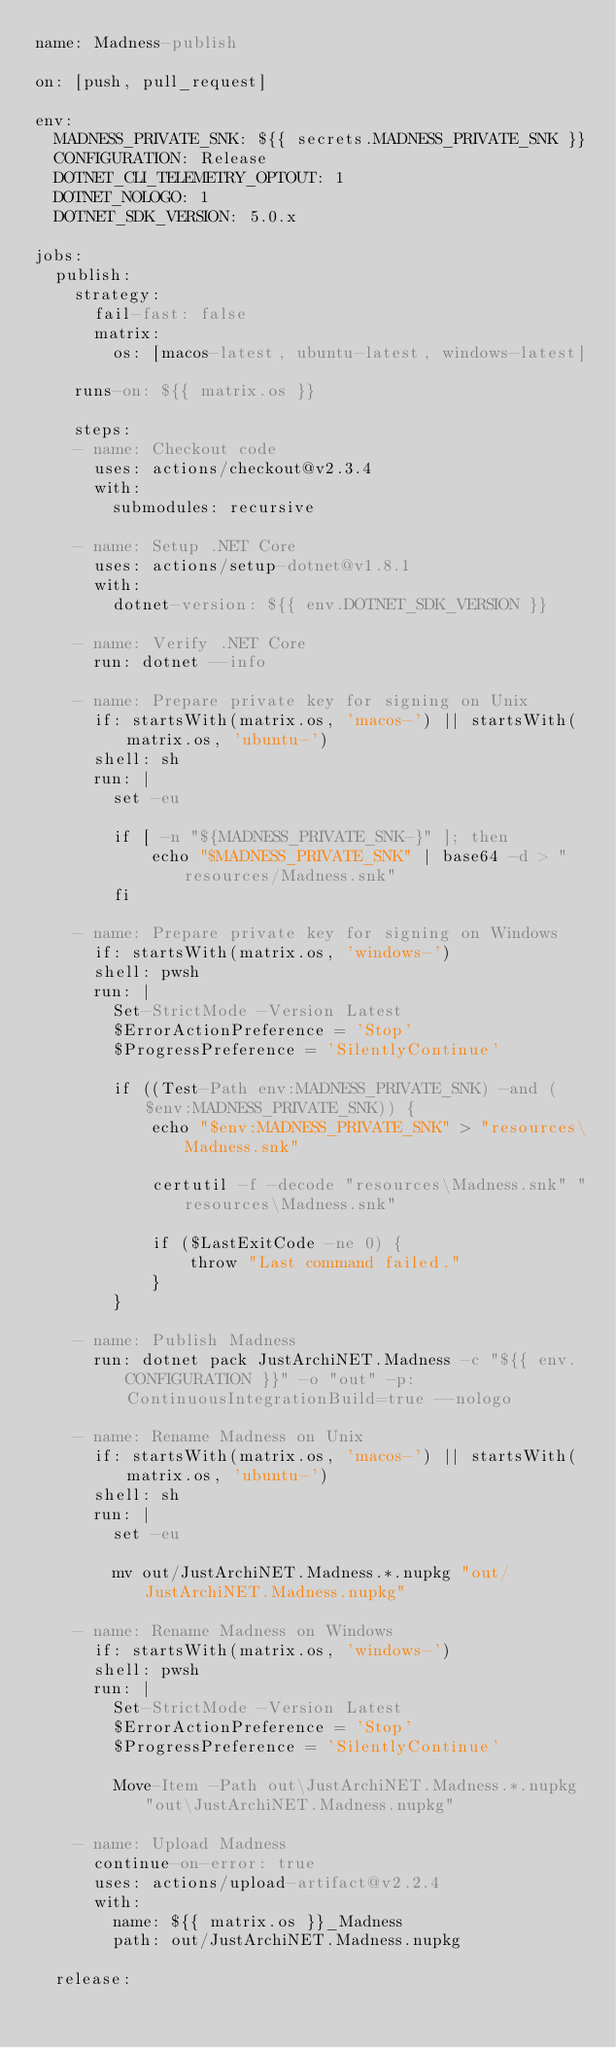<code> <loc_0><loc_0><loc_500><loc_500><_YAML_>name: Madness-publish

on: [push, pull_request]

env:
  MADNESS_PRIVATE_SNK: ${{ secrets.MADNESS_PRIVATE_SNK }}
  CONFIGURATION: Release
  DOTNET_CLI_TELEMETRY_OPTOUT: 1
  DOTNET_NOLOGO: 1
  DOTNET_SDK_VERSION: 5.0.x

jobs:
  publish:
    strategy:
      fail-fast: false
      matrix:
        os: [macos-latest, ubuntu-latest, windows-latest]

    runs-on: ${{ matrix.os }}

    steps:
    - name: Checkout code
      uses: actions/checkout@v2.3.4
      with:
        submodules: recursive

    - name: Setup .NET Core
      uses: actions/setup-dotnet@v1.8.1
      with:
        dotnet-version: ${{ env.DOTNET_SDK_VERSION }}

    - name: Verify .NET Core
      run: dotnet --info

    - name: Prepare private key for signing on Unix
      if: startsWith(matrix.os, 'macos-') || startsWith(matrix.os, 'ubuntu-')
      shell: sh
      run: |
        set -eu

        if [ -n "${MADNESS_PRIVATE_SNK-}" ]; then
            echo "$MADNESS_PRIVATE_SNK" | base64 -d > "resources/Madness.snk"
        fi

    - name: Prepare private key for signing on Windows
      if: startsWith(matrix.os, 'windows-')
      shell: pwsh
      run: |
        Set-StrictMode -Version Latest
        $ErrorActionPreference = 'Stop'
        $ProgressPreference = 'SilentlyContinue'

        if ((Test-Path env:MADNESS_PRIVATE_SNK) -and ($env:MADNESS_PRIVATE_SNK)) {
            echo "$env:MADNESS_PRIVATE_SNK" > "resources\Madness.snk"

            certutil -f -decode "resources\Madness.snk" "resources\Madness.snk"

            if ($LastExitCode -ne 0) {
                throw "Last command failed."
            }
        }

    - name: Publish Madness
      run: dotnet pack JustArchiNET.Madness -c "${{ env.CONFIGURATION }}" -o "out" -p:ContinuousIntegrationBuild=true --nologo

    - name: Rename Madness on Unix
      if: startsWith(matrix.os, 'macos-') || startsWith(matrix.os, 'ubuntu-')
      shell: sh
      run: |
        set -eu

        mv out/JustArchiNET.Madness.*.nupkg "out/JustArchiNET.Madness.nupkg"

    - name: Rename Madness on Windows
      if: startsWith(matrix.os, 'windows-')
      shell: pwsh
      run: |
        Set-StrictMode -Version Latest
        $ErrorActionPreference = 'Stop'
        $ProgressPreference = 'SilentlyContinue'

        Move-Item -Path out\JustArchiNET.Madness.*.nupkg "out\JustArchiNET.Madness.nupkg"

    - name: Upload Madness
      continue-on-error: true
      uses: actions/upload-artifact@v2.2.4
      with:
        name: ${{ matrix.os }}_Madness
        path: out/JustArchiNET.Madness.nupkg

  release:</code> 